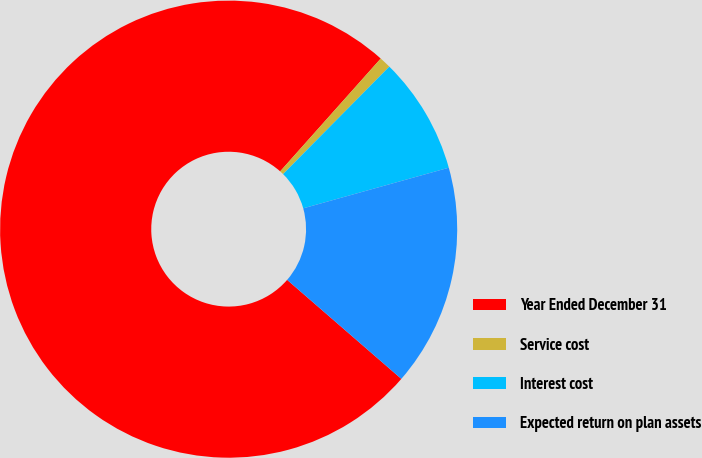<chart> <loc_0><loc_0><loc_500><loc_500><pie_chart><fcel>Year Ended December 31<fcel>Service cost<fcel>Interest cost<fcel>Expected return on plan assets<nl><fcel>75.22%<fcel>0.82%<fcel>8.26%<fcel>15.7%<nl></chart> 